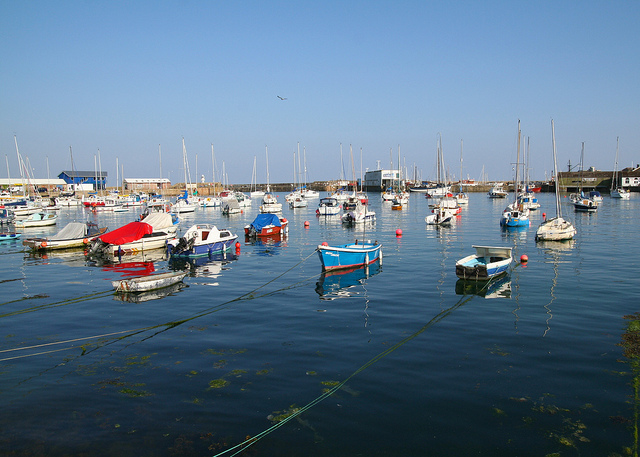Can you describe the weather conditions in the image? The weather in the image is quite clear, with blue skies and sunshine suggesting a pleasant and likely warm day, ideal for maritime activities. 